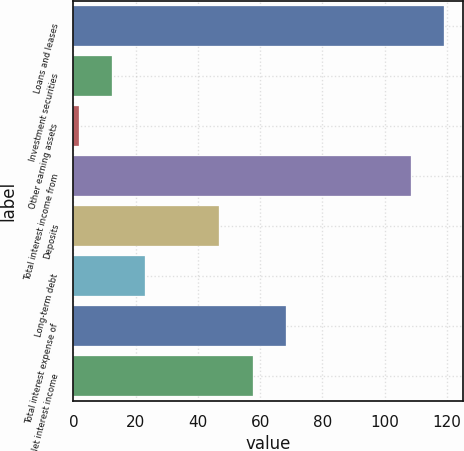Convert chart to OTSL. <chart><loc_0><loc_0><loc_500><loc_500><bar_chart><fcel>Loans and leases<fcel>Investment securities<fcel>Other earning assets<fcel>Total interest income from<fcel>Deposits<fcel>Long-term debt<fcel>Total interest expense of<fcel>Net interest income<nl><fcel>119.1<fcel>12.4<fcel>1.7<fcel>108.4<fcel>46.9<fcel>23.1<fcel>68.3<fcel>57.6<nl></chart> 